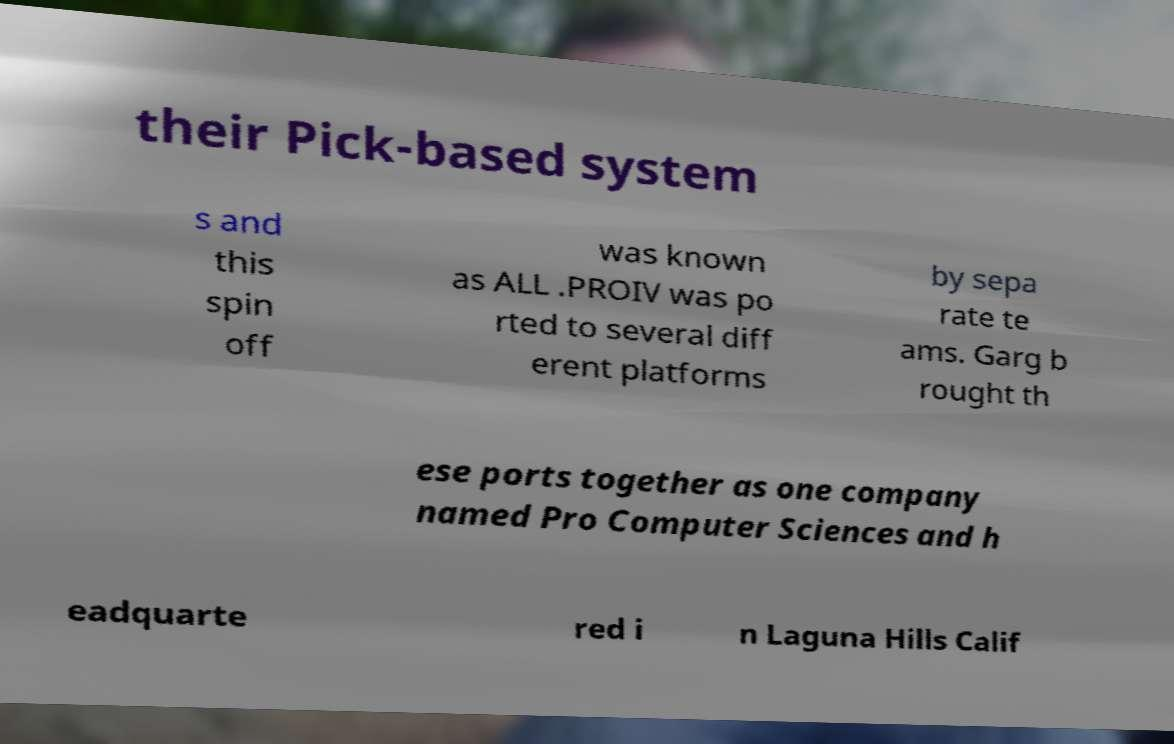Could you extract and type out the text from this image? their Pick-based system s and this spin off was known as ALL .PROIV was po rted to several diff erent platforms by sepa rate te ams. Garg b rought th ese ports together as one company named Pro Computer Sciences and h eadquarte red i n Laguna Hills Calif 